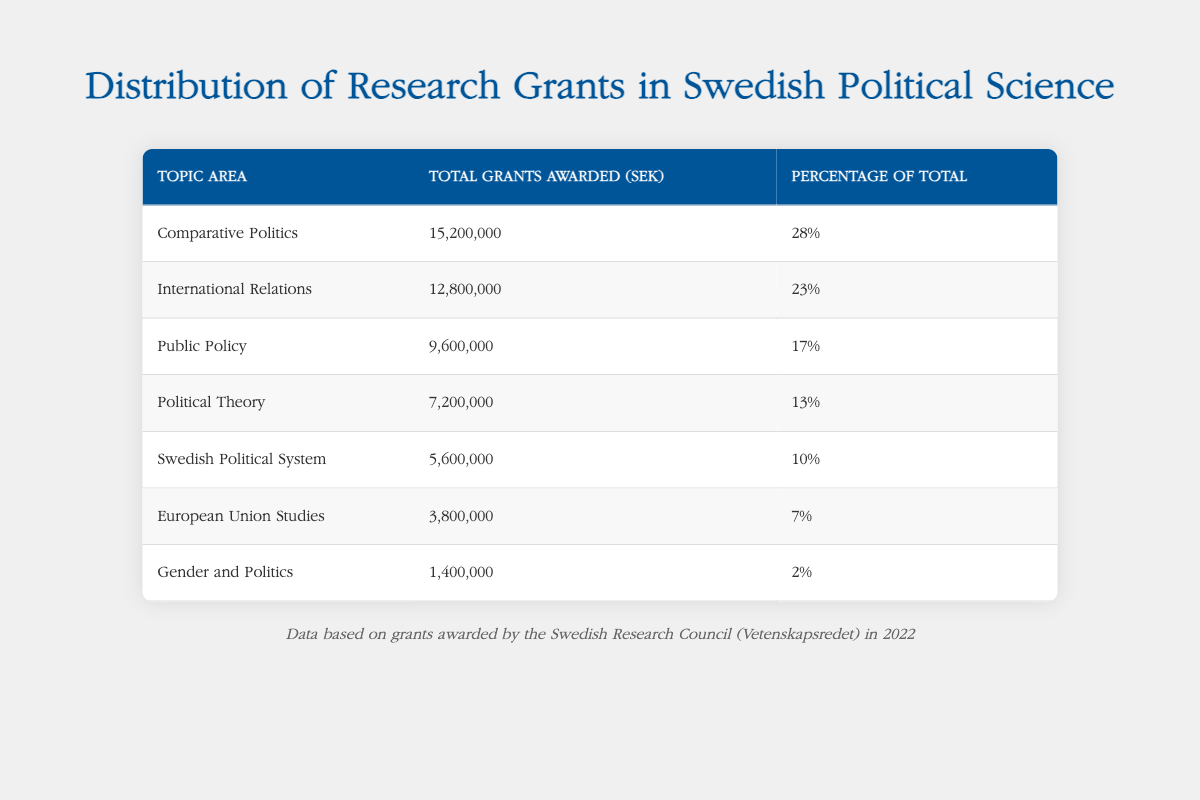What is the total amount awarded for Gender and Politics? The table lists the total grants awarded for Gender and Politics as 1,400,000 SEK.
Answer: 1,400,000 SEK Which topic area received the highest percentage of total grants? The highest percentage of total grants is for Comparative Politics, which received 28%.
Answer: Comparative Politics What is the sum of the grants awarded for Public Policy and Political Theory? The grants awarded for Public Policy is 9,600,000 SEK and for Political Theory is 7,200,000 SEK. Their sum is 9,600,000 + 7,200,000 = 16,800,000 SEK.
Answer: 16,800,000 SEK Is the grant amount for Swedish Political System greater than that for European Union Studies? The grant for Swedish Political System is 5,600,000 SEK, while for European Union Studies it is 3,800,000 SEK. Therefore, 5,600,000 is greater than 3,800,000.
Answer: Yes What is the average grant amount awarded across all the topic areas? To find the average, we first sum all the grants: (15,200,000 + 12,800,000 + 9,600,000 + 7,200,000 + 5,600,000 + 3,800,000 + 1,400,000) = 55,600,000 SEK. There are 7 topic areas, so the average is 55,600,000 / 7 = 7,957,143 SEK (rounded).
Answer: 7,957,143 SEK 